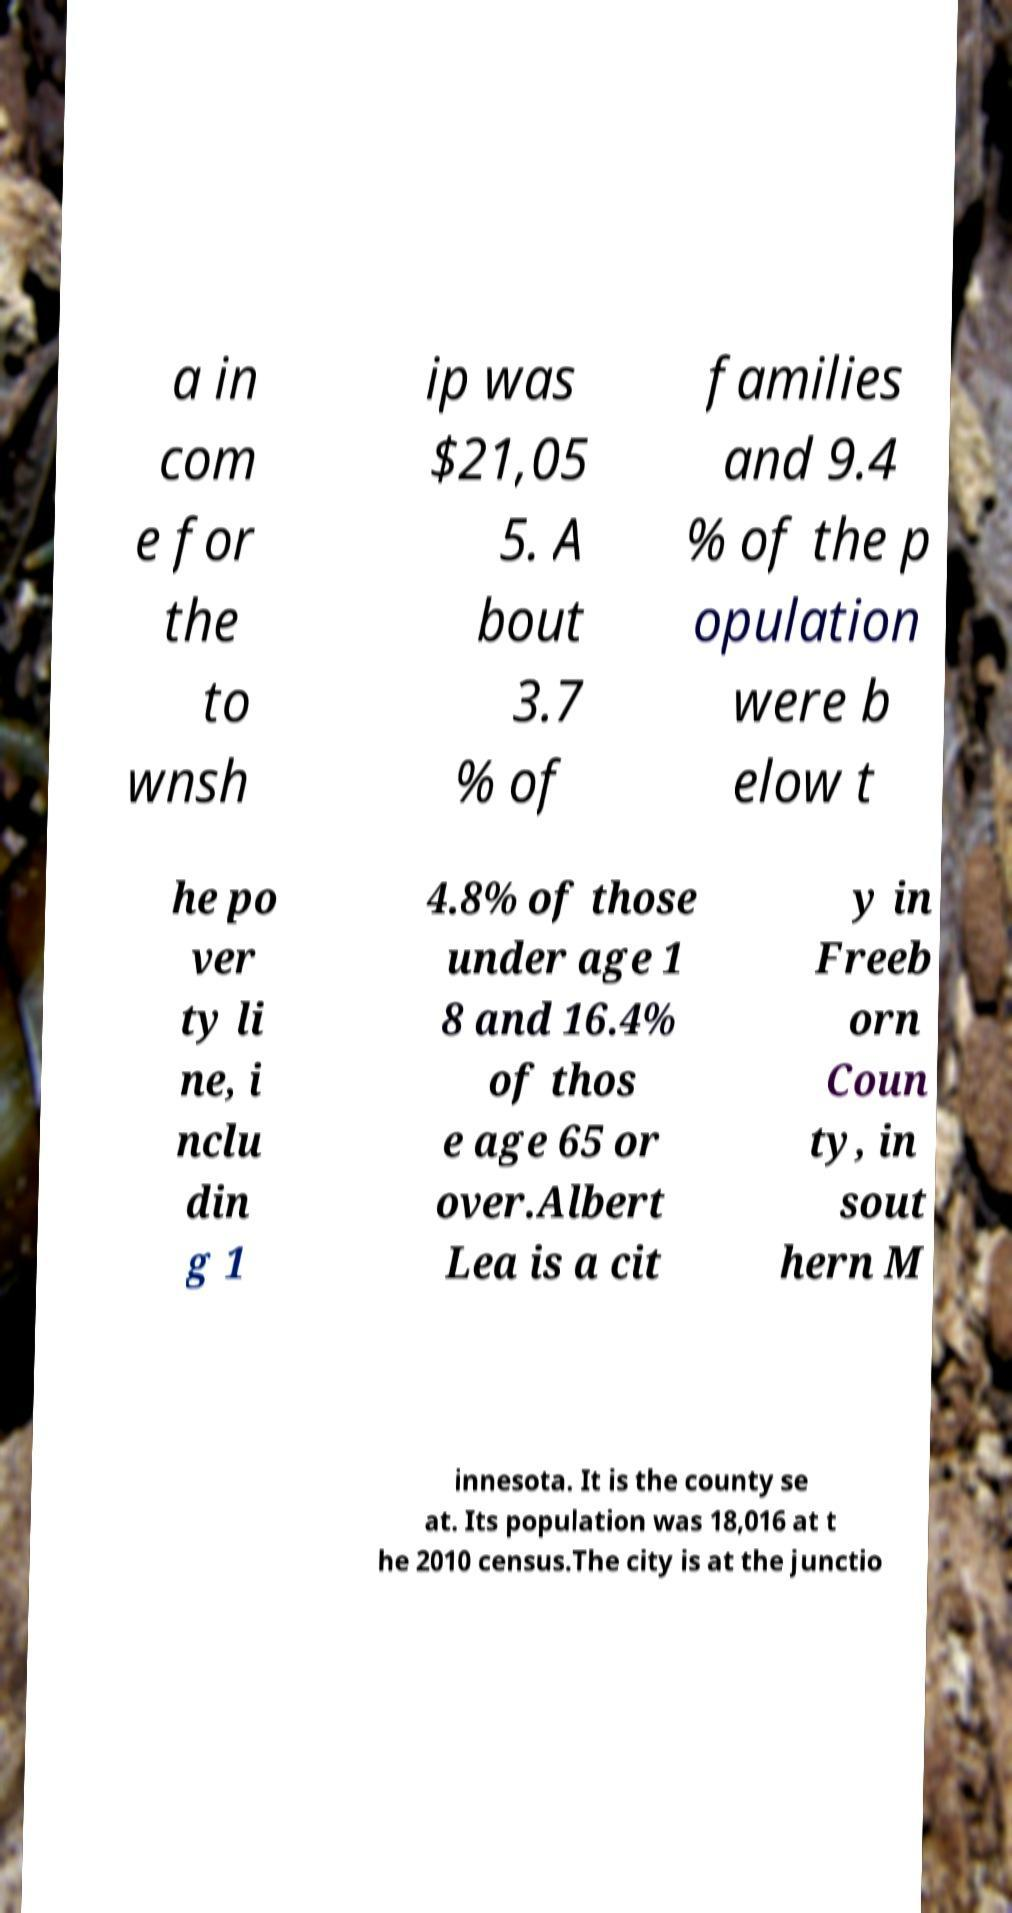What messages or text are displayed in this image? I need them in a readable, typed format. a in com e for the to wnsh ip was $21,05 5. A bout 3.7 % of families and 9.4 % of the p opulation were b elow t he po ver ty li ne, i nclu din g 1 4.8% of those under age 1 8 and 16.4% of thos e age 65 or over.Albert Lea is a cit y in Freeb orn Coun ty, in sout hern M innesota. It is the county se at. Its population was 18,016 at t he 2010 census.The city is at the junctio 